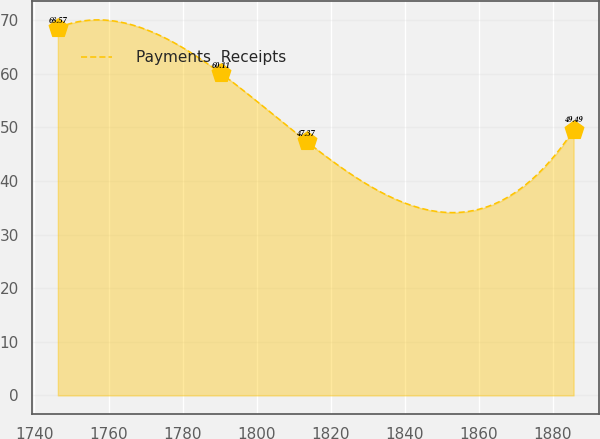<chart> <loc_0><loc_0><loc_500><loc_500><line_chart><ecel><fcel>Payments  Receipts<nl><fcel>1746.31<fcel>68.57<nl><fcel>1790.3<fcel>60.11<nl><fcel>1813.5<fcel>47.37<nl><fcel>1885.66<fcel>49.49<nl></chart> 